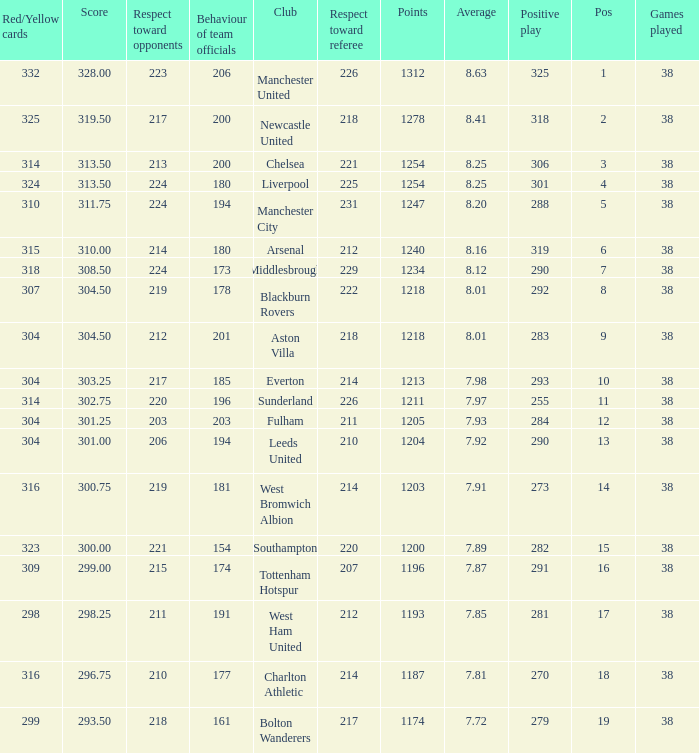Name the pos for west ham united 17.0. 